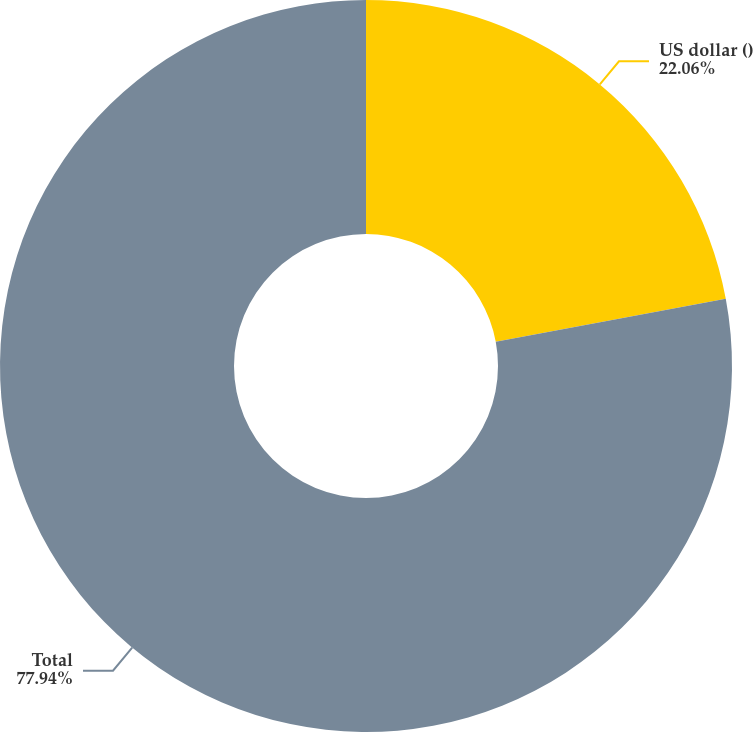Convert chart. <chart><loc_0><loc_0><loc_500><loc_500><pie_chart><fcel>US dollar ()<fcel>Total<nl><fcel>22.06%<fcel>77.94%<nl></chart> 